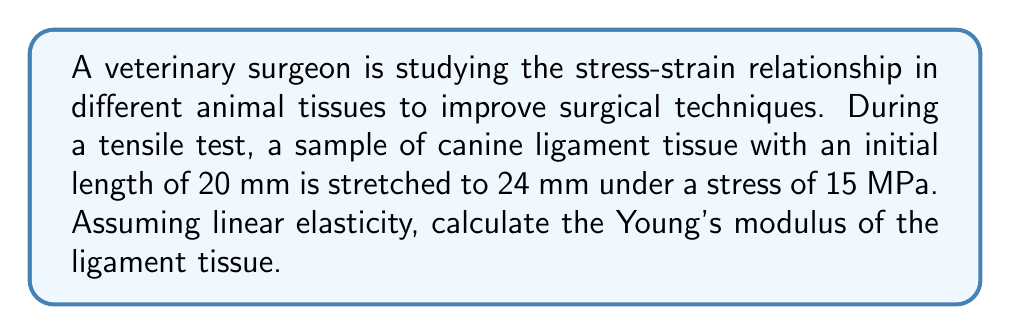Could you help me with this problem? To solve this problem, we'll use the following steps:

1) First, recall the definition of Young's modulus:

   $$ E = \frac{\text{stress}}{\text{strain}} $$

   where $E$ is Young's modulus, stress is force per unit area, and strain is the relative change in length.

2) We're given the stress: 15 MPa

3) We need to calculate the strain:
   
   Strain $\varepsilon = \frac{\Delta L}{L_0}$

   where $\Delta L$ is the change in length and $L_0$ is the initial length.

   $\Delta L = 24 \text{ mm} - 20 \text{ mm} = 4 \text{ mm}$
   $L_0 = 20 \text{ mm}$

   $$ \varepsilon = \frac{4 \text{ mm}}{20 \text{ mm}} = 0.2 $$

4) Now we can calculate Young's modulus:

   $$ E = \frac{\text{stress}}{\text{strain}} = \frac{15 \text{ MPa}}{0.2} = 75 \text{ MPa} $$

Therefore, the Young's modulus of the canine ligament tissue is 75 MPa.
Answer: 75 MPa 